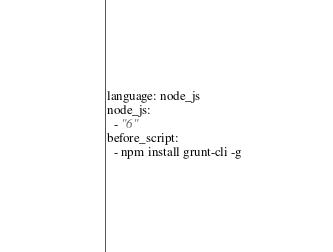<code> <loc_0><loc_0><loc_500><loc_500><_YAML_>language: node_js
node_js:
  - "6"
before_script:
  - npm install grunt-cli -g
</code> 